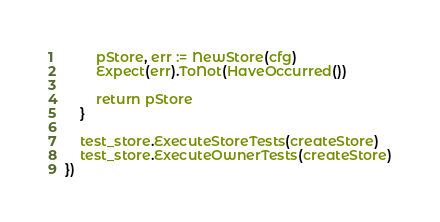Convert code to text. <code><loc_0><loc_0><loc_500><loc_500><_Go_>
		pStore, err := NewStore(cfg)
		Expect(err).ToNot(HaveOccurred())

		return pStore
	}

	test_store.ExecuteStoreTests(createStore)
	test_store.ExecuteOwnerTests(createStore)
})
</code> 